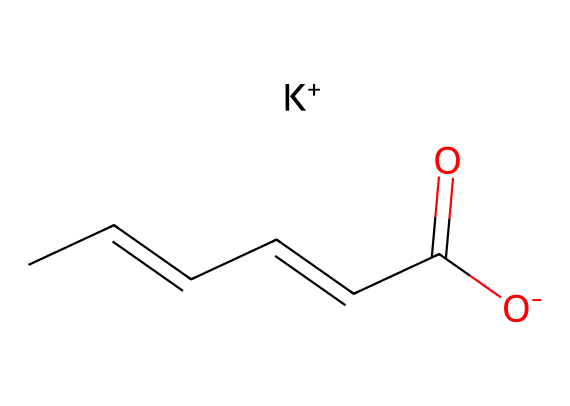how many carbon atoms are in potassium sorbate? The SMILES representation contains six carbon atoms represented by "C" in the structure.
Answer: 6 what is the molecular formula for potassium sorbate? By combining the identified atoms (C, H, O, K) in the SMILES representation, the molecular formula can be derived as C6H7O2K.
Answer: C6H7O2K which functional group is present in potassium sorbate? The carboxylate group (-COO-) is identified within the structure, which is evident from the carbonyl (C=O) and hydroxyl (O-) components.
Answer: carboxylate how does potassium sorbate inhibit microbial growth? Potassium sorbate acts as a preservative due to the structural feature of the sorbate ion, which interferes with the normal metabolic processes of mold and yeast.
Answer: structural feature which property of potassium sorbate contributes to its function as a food preservative? The molecule’s ability to be dissociated into sorbate ions in solution enhances its efficacy in preventing spoilage by low pH.
Answer: dissociation what is the significance of the potassium ion in potassium sorbate? The potassium ion (K+) provides the ionic form of the compound that enhances solubility and stability in food products, making it an effective preservative.
Answer: enhances solubility what is the typical pH range for effective preservation by potassium sorbate? The compound is most effective as a preservative in a pH range below 6.5, which can be deduced from its pKa values related to the carboxylate group.
Answer: below 6.5 